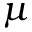Convert formula to latex. <formula><loc_0><loc_0><loc_500><loc_500>\mu</formula> 